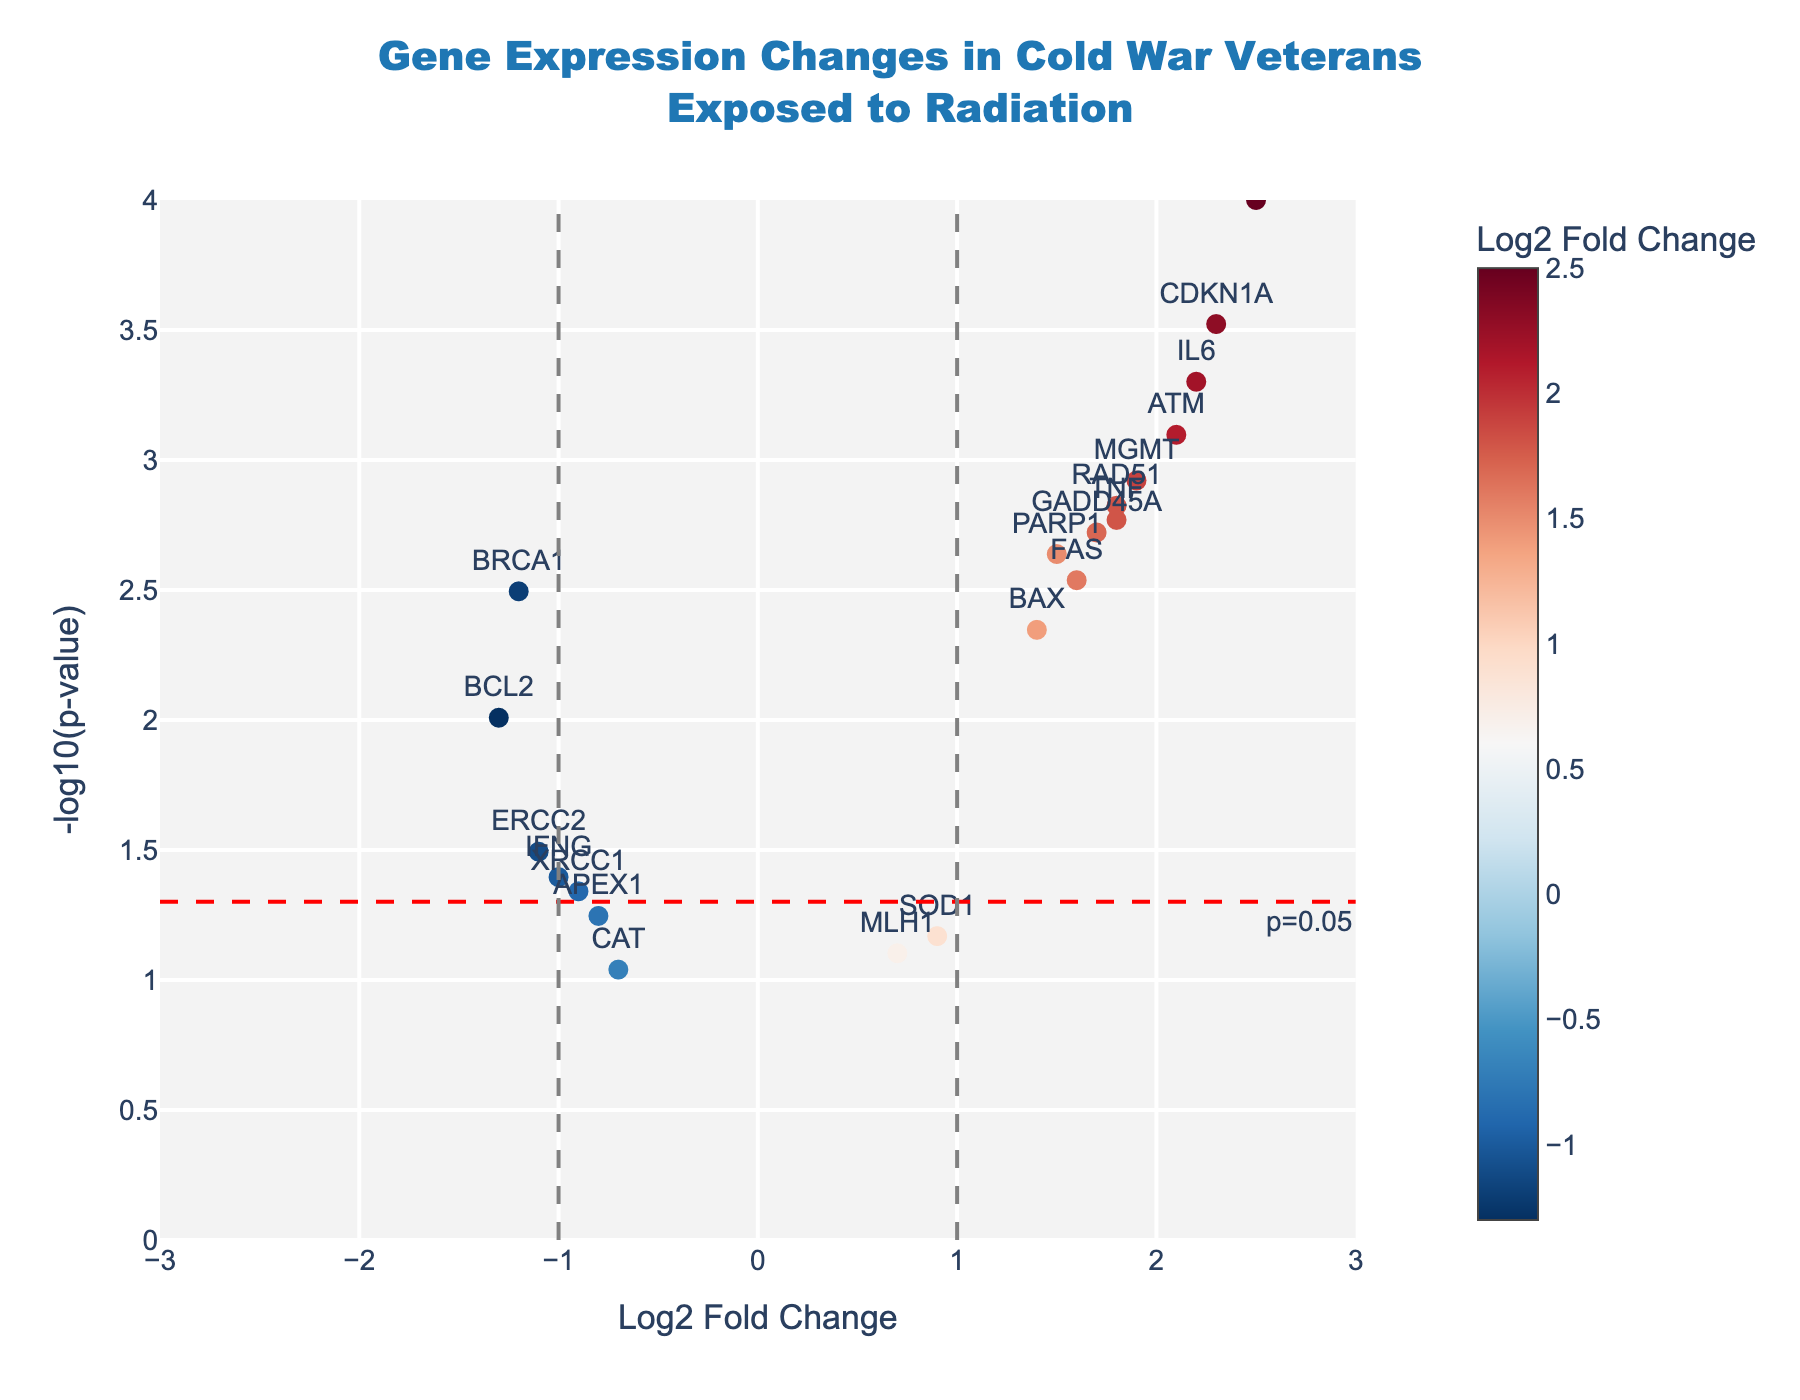How many genes are plotted on the figure? Count each data point representing a gene on the volcano plot. There are 20 unique genes listed in the data.
Answer: 20 What color scale is used for the markers representing Log2 Fold Change? The markers use a color scale from red to blue, indicated by 'RdBu_r' in the code, which typically shows reds for negative changes and blues for positive changes.
Answer: Red to Blue (RdBu_r) Which gene shows the highest Log2 Fold Change? Identify the gene with the highest value on the x-axis. TP53 has a Log2 Fold Change of 2.5, the highest among the listed genes.
Answer: TP53 Which gene shows the lowest p-value? Find the gene with the highest -log10(p-value) on the y-axis, indicative of the lowest p-value. TP53 has the highest -log10(p-value).
Answer: TP53 How many genes have a Log2 Fold Change greater than 1? Count the number of data points to the right of the vertical line at x=1. There are 7 genes (TP53, ATM, MGMT, CDKN1A, GADD45A, IL6, TNF) with Log2 Fold Change greater than 1.
Answer: 7 Which genes are significantly downregulated (Log2 Fold Change < -1 and p-value < 0.05)? Identify points below x=-1 and above the horizontal red line indicating p-value < 0.05. BRCA1, BCL2, and ERCC2 meet these criteria.
Answer: BRCA1, BCL2, ERCC2 What is the significance threshold for the p-value indicated by the horizontal line? The horizontal dashed red line represents -log10(p-value) = -log10(0.05), which converts to approximately 1.3 in the plot.
Answer: 0.05 How many genes have a significantly different expression (p-value < 0.05)? Count the number of genes plotted above the horizontal red line, which represents a p-value threshold of 0.05. There are 15 genes above the -log10(p-value) of 1.3.
Answer: 15 Which two genes have the closest Log2 Fold Change values but different p-values, between -1 and 1 fold change? Look for close x-values in the -1 to 1 range and compare their y-values. SOD1 and MLH1 both fall within this range with Log2 Fold Changes of 0.9 and 0.7, respectively, but differing p-values of 0.0678 and 0.0789.
Answer: SOD1 and MLH1 